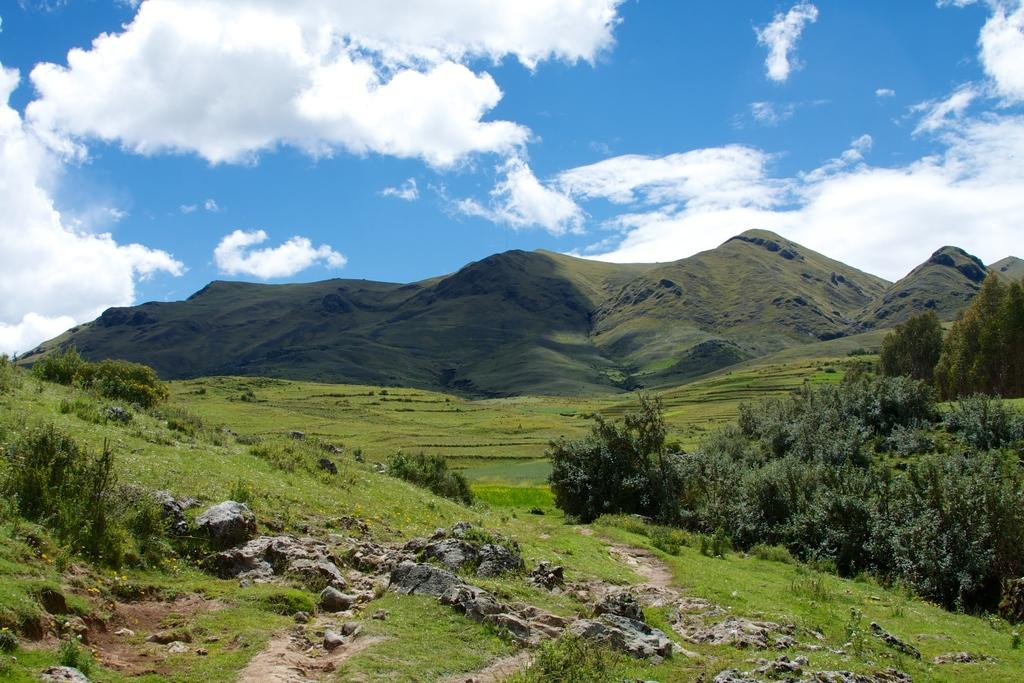What type of vegetation can be seen in the image? There are plants, grass, and trees in the image. What type of terrain is visible in the image? There are stones and mountains in the image. What is visible in the background of the image? The sky is visible in the background of the image. What can be seen in the sky? There are clouds in the sky. What type of feast is being prepared on the edge of the mountain in the image? There is no feast or preparation visible in the image; it only shows plants, grass, trees, stones, mountains, sky, and clouds. 